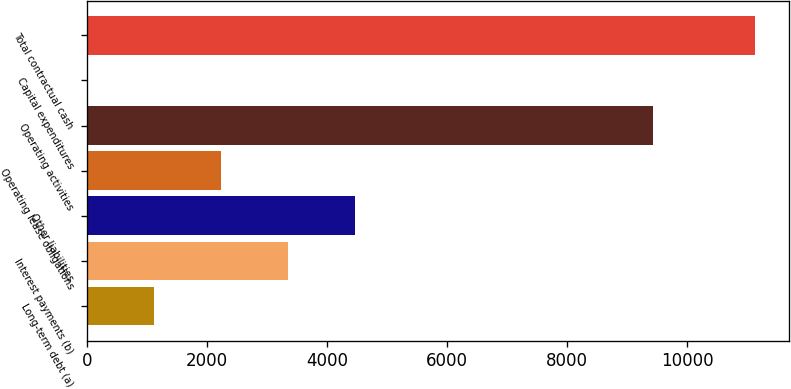Convert chart to OTSL. <chart><loc_0><loc_0><loc_500><loc_500><bar_chart><fcel>Long-term debt (a)<fcel>Interest payments (b)<fcel>Other liabilities<fcel>Operating lease obligations<fcel>Operating activities<fcel>Capital expenditures<fcel>Total contractual cash<nl><fcel>1123.9<fcel>3349.7<fcel>4462.6<fcel>2236.8<fcel>9432<fcel>11<fcel>11140<nl></chart> 